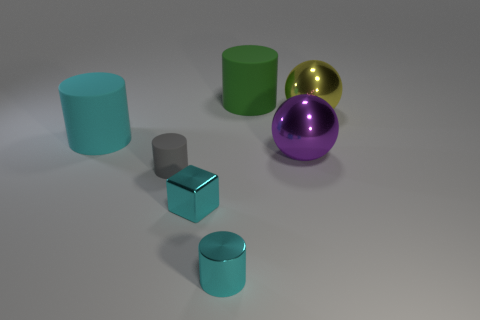Add 1 tiny metallic objects. How many objects exist? 8 Subtract all cylinders. How many objects are left? 3 Subtract 0 purple cylinders. How many objects are left? 7 Subtract all big brown cubes. Subtract all big green cylinders. How many objects are left? 6 Add 4 large cyan rubber cylinders. How many large cyan rubber cylinders are left? 5 Add 1 purple metallic spheres. How many purple metallic spheres exist? 2 